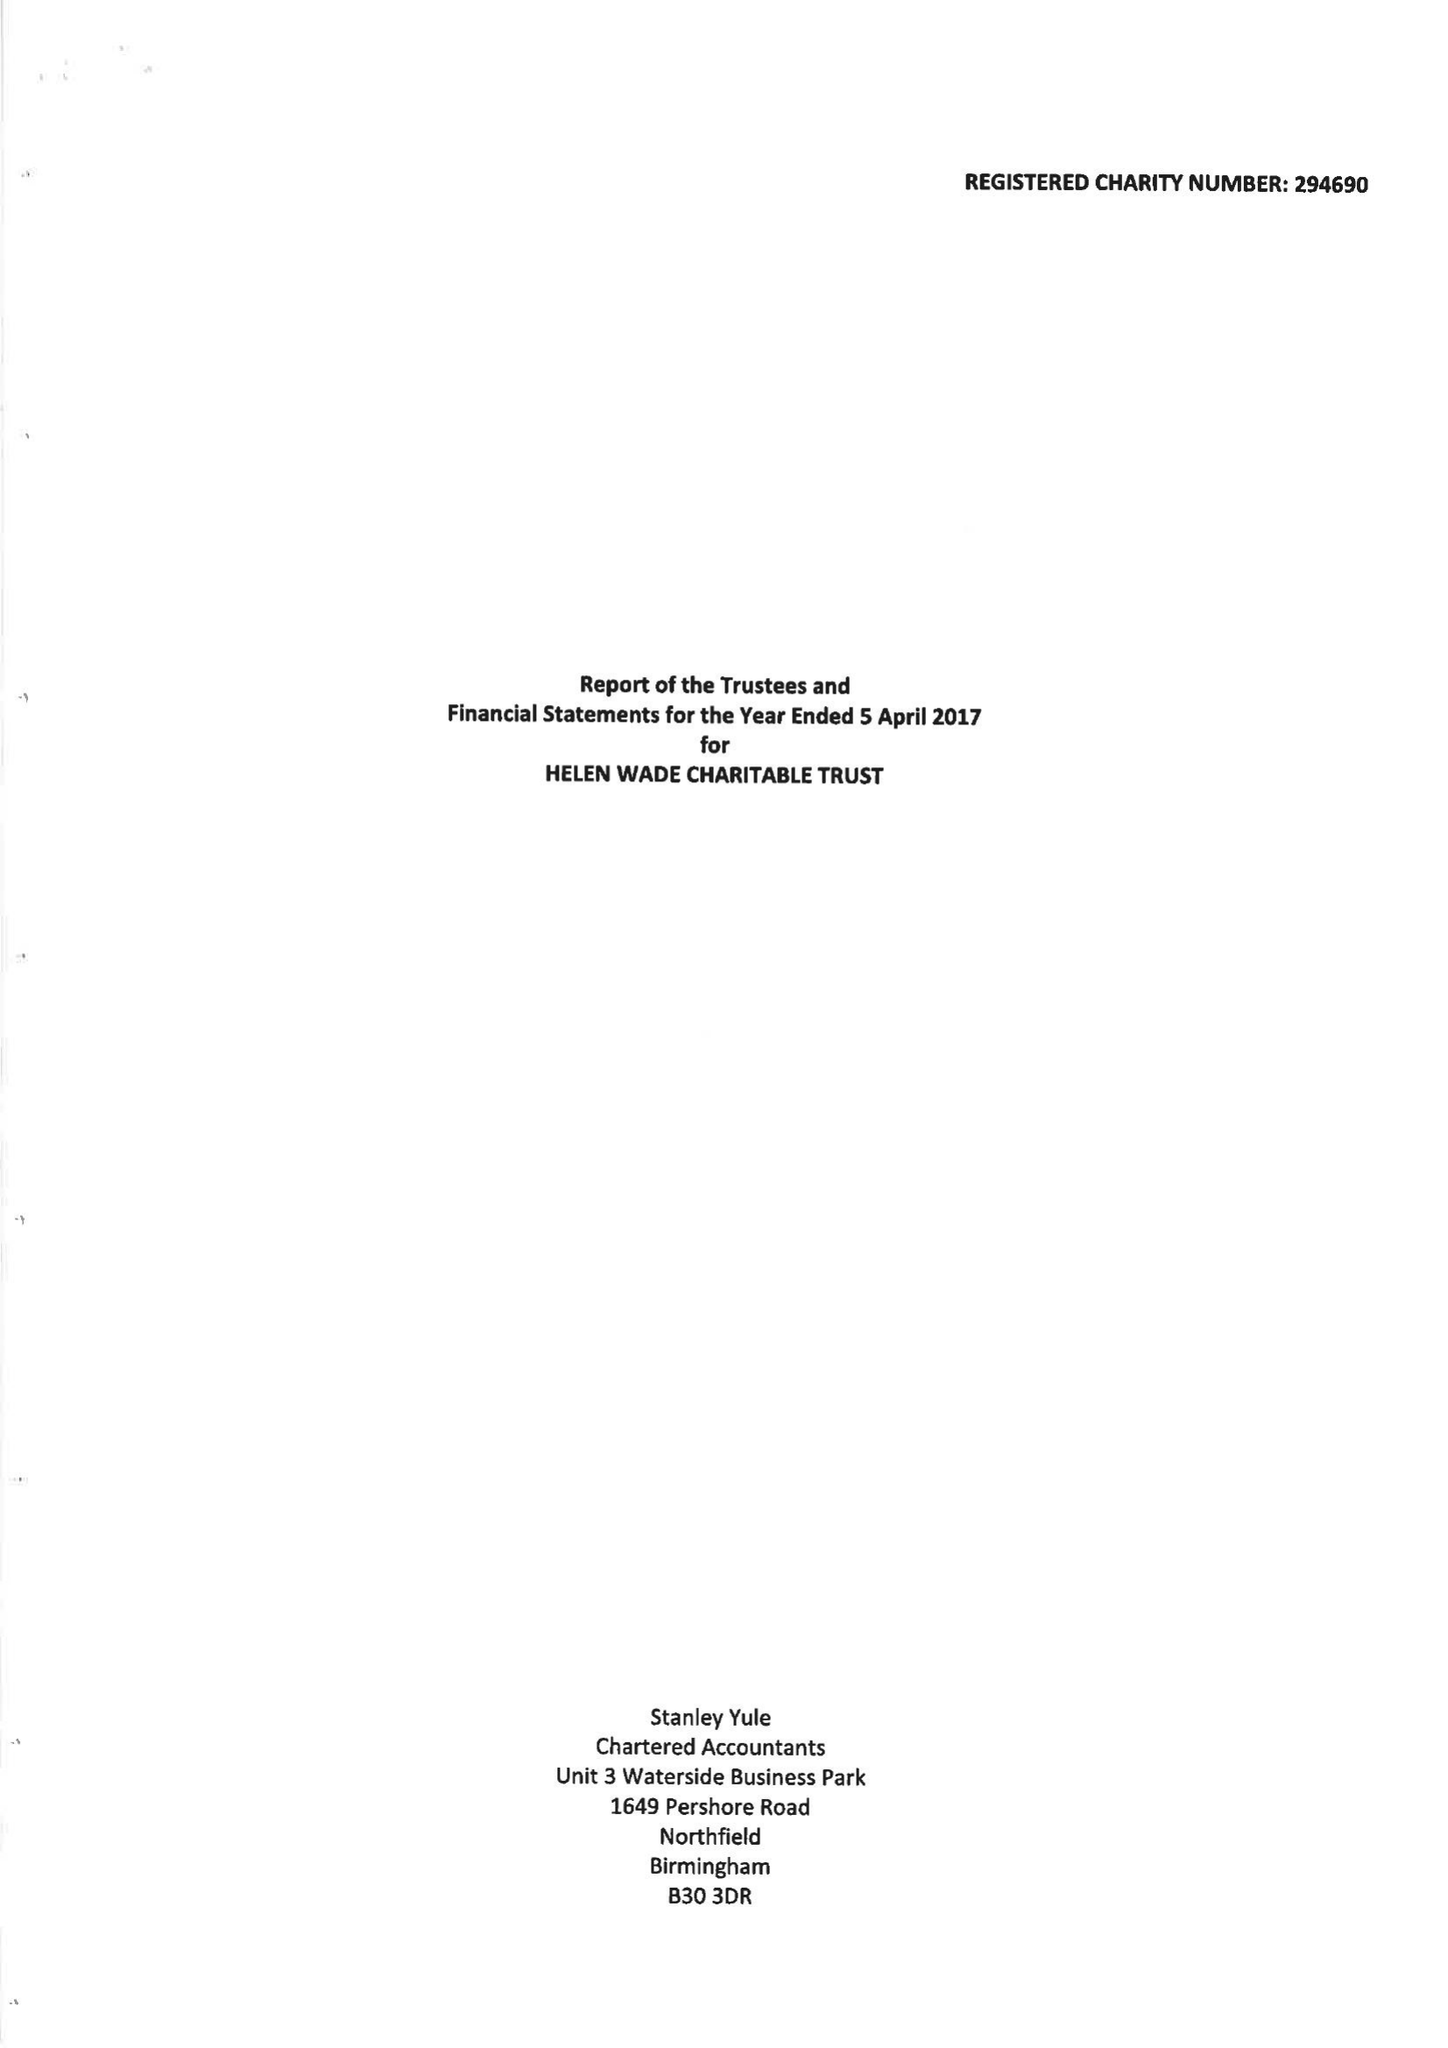What is the value for the spending_annually_in_british_pounds?
Answer the question using a single word or phrase. 9683.00 